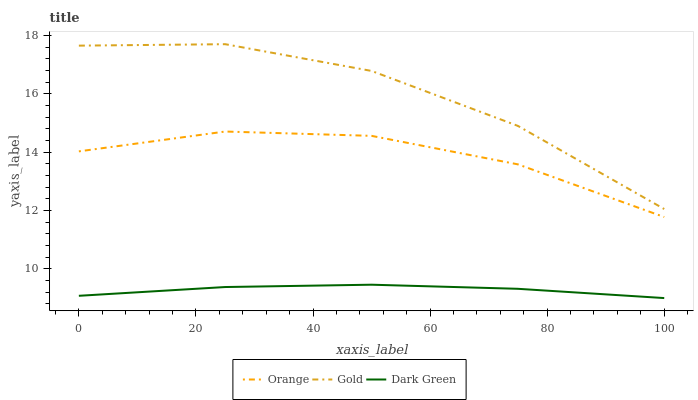Does Dark Green have the minimum area under the curve?
Answer yes or no. Yes. Does Gold have the maximum area under the curve?
Answer yes or no. Yes. Does Gold have the minimum area under the curve?
Answer yes or no. No. Does Dark Green have the maximum area under the curve?
Answer yes or no. No. Is Dark Green the smoothest?
Answer yes or no. Yes. Is Gold the roughest?
Answer yes or no. Yes. Is Gold the smoothest?
Answer yes or no. No. Is Dark Green the roughest?
Answer yes or no. No. Does Dark Green have the lowest value?
Answer yes or no. Yes. Does Gold have the lowest value?
Answer yes or no. No. Does Gold have the highest value?
Answer yes or no. Yes. Does Dark Green have the highest value?
Answer yes or no. No. Is Dark Green less than Orange?
Answer yes or no. Yes. Is Gold greater than Dark Green?
Answer yes or no. Yes. Does Dark Green intersect Orange?
Answer yes or no. No. 